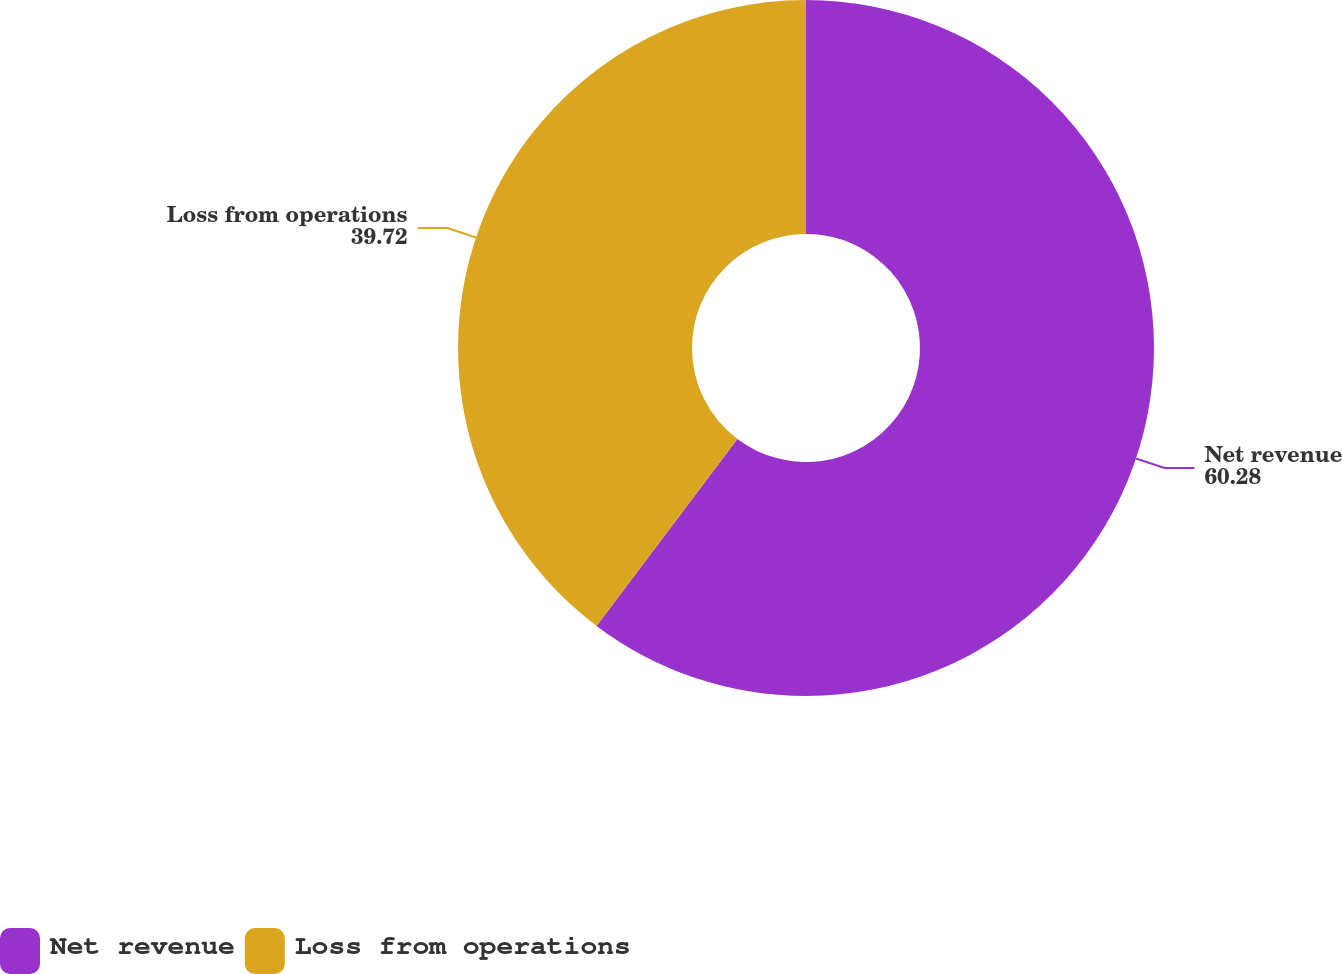<chart> <loc_0><loc_0><loc_500><loc_500><pie_chart><fcel>Net revenue<fcel>Loss from operations<nl><fcel>60.28%<fcel>39.72%<nl></chart> 